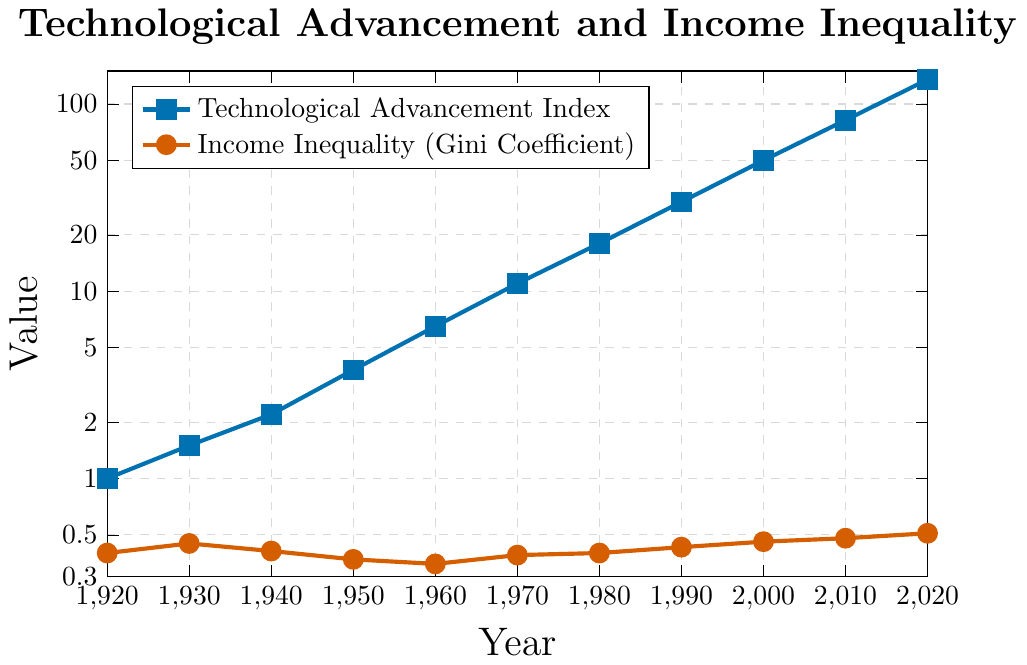What's the overall trend of the Technological Advancement Index from 1920 to 2020? The Technological Advancement Index shows a consistent exponential increase from 1920 (value of 1) to 2020 (value of 135).
Answer: Exponential increase How does the Gini Coefficient change from 1920 to 2020? The Gini Coefficient generally increases from 0.40 in 1920 to 0.51 in 2020, with fluctuations along the way.
Answer: Generally increases In which decade did the Technological Advancement Index see the highest rate of growth? Comparing the differences decade by decade, the highest growth occurred between 2010 (82) and 2020 (135), where the index increased by 53.
Answer: 2010-2020 What is the percentage increase in the Gini Coefficient from 1920 to 2020? The Gini Coefficient increased from 0.40 in 1920 to 0.51 in 2020. The percentage increase is calculated as \((0.51 - 0.40) / 0.40 \times 100 = 27.5\%\).
Answer: 27.5% Which year had the highest Gini Coefficient, and what was its value? The highest Gini Coefficient is observed in 2020 with a value of 0.51.
Answer: 2020, 0.51 Does the Gini Coefficient show any significant dips, and if so, when? The Gini Coefficient shows a significant dip in 1950 with a value of 0.37, which is the lowest in the entire period.
Answer: 1950 How does the Gini Coefficient in 1980 compare to 2020? In 1980, the Gini Coefficient was 0.40, and by 2020, it had risen to 0.51, indicating an increase.
Answer: Increased Between which consecutive decades did the Technological Advancement Index increase by the most? Comparing the increase between each consecutive decade, the largest increase occurs between 1990 and 2000, where the index increased from 30 to 50, a difference of 20.
Answer: 1990-2000 What's the average value of the Technological Advancement Index during the 20th century (1920-1999)? The values from 1920 to 1999 are: 1, 1.5, 2.2, 3.8, 6.5, 11, 18, 30. The sum is 74, and there are 8 values. The average is 74 / 8 = 9.25.
Answer: 9.25 Is there a correlation between the increase in the Technological Advancement Index and the Gini Coefficient from 1920 to 2020? Both the Technological Advancement Index and the Gini Coefficient show an overall increasing trend from 1920 to 2020, suggesting a potential correlation where technological advancements are associated with increased income inequality.
Answer: Potential correlation 